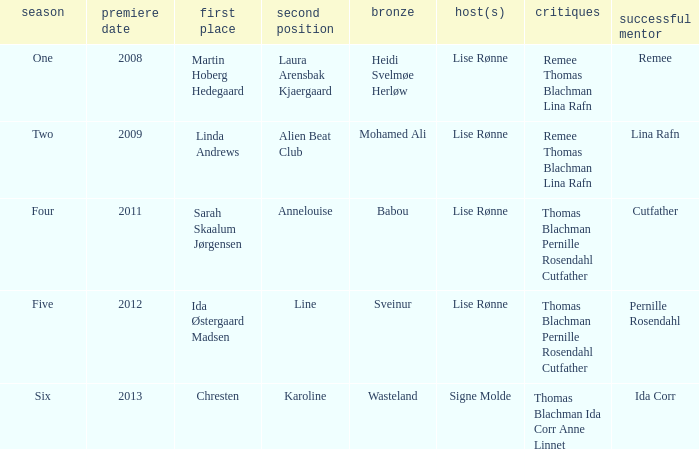Who was the winning mentor in season two? Lina Rafn. 